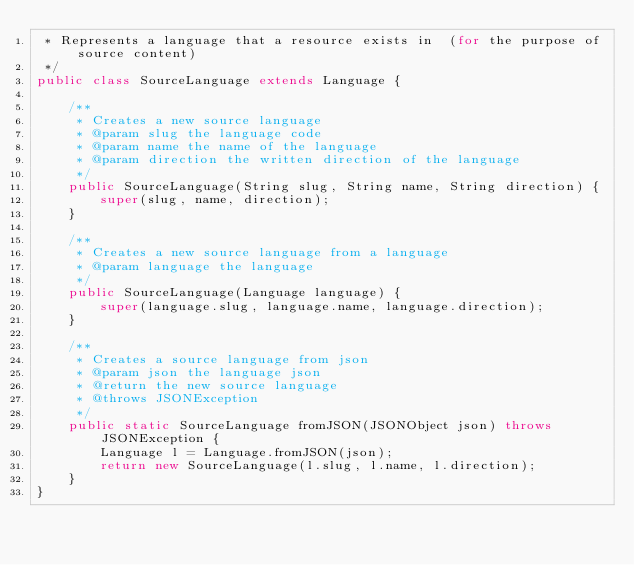<code> <loc_0><loc_0><loc_500><loc_500><_Java_> * Represents a language that a resource exists in  (for the purpose of source content)
 */
public class SourceLanguage extends Language {

    /**
     * Creates a new source language
     * @param slug the language code
     * @param name the name of the language
     * @param direction the written direction of the language
     */
    public SourceLanguage(String slug, String name, String direction) {
        super(slug, name, direction);
    }

    /**
     * Creates a new source language from a language
     * @param language the language
     */
    public SourceLanguage(Language language) {
        super(language.slug, language.name, language.direction);
    }

    /**
     * Creates a source language from json
     * @param json the language json
     * @return the new source language
     * @throws JSONException
     */
    public static SourceLanguage fromJSON(JSONObject json) throws JSONException {
        Language l = Language.fromJSON(json);
        return new SourceLanguage(l.slug, l.name, l.direction);
    }
}
</code> 